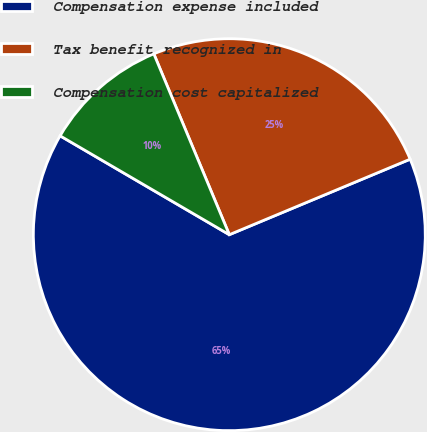<chart> <loc_0><loc_0><loc_500><loc_500><pie_chart><fcel>Compensation expense included<fcel>Tax benefit recognized in<fcel>Compensation cost capitalized<nl><fcel>64.71%<fcel>25.0%<fcel>10.29%<nl></chart> 